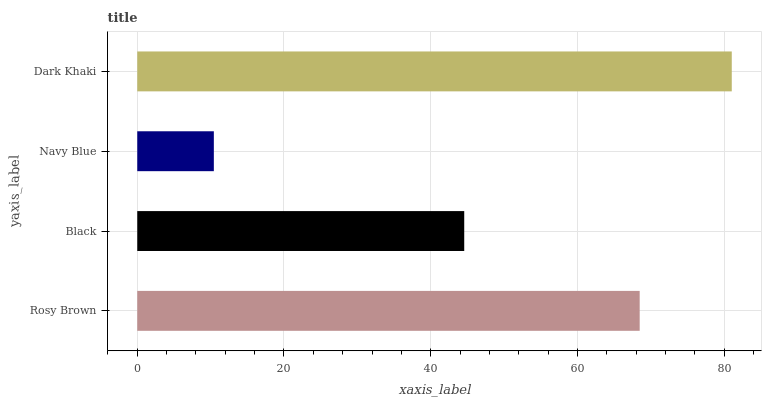Is Navy Blue the minimum?
Answer yes or no. Yes. Is Dark Khaki the maximum?
Answer yes or no. Yes. Is Black the minimum?
Answer yes or no. No. Is Black the maximum?
Answer yes or no. No. Is Rosy Brown greater than Black?
Answer yes or no. Yes. Is Black less than Rosy Brown?
Answer yes or no. Yes. Is Black greater than Rosy Brown?
Answer yes or no. No. Is Rosy Brown less than Black?
Answer yes or no. No. Is Rosy Brown the high median?
Answer yes or no. Yes. Is Black the low median?
Answer yes or no. Yes. Is Dark Khaki the high median?
Answer yes or no. No. Is Dark Khaki the low median?
Answer yes or no. No. 